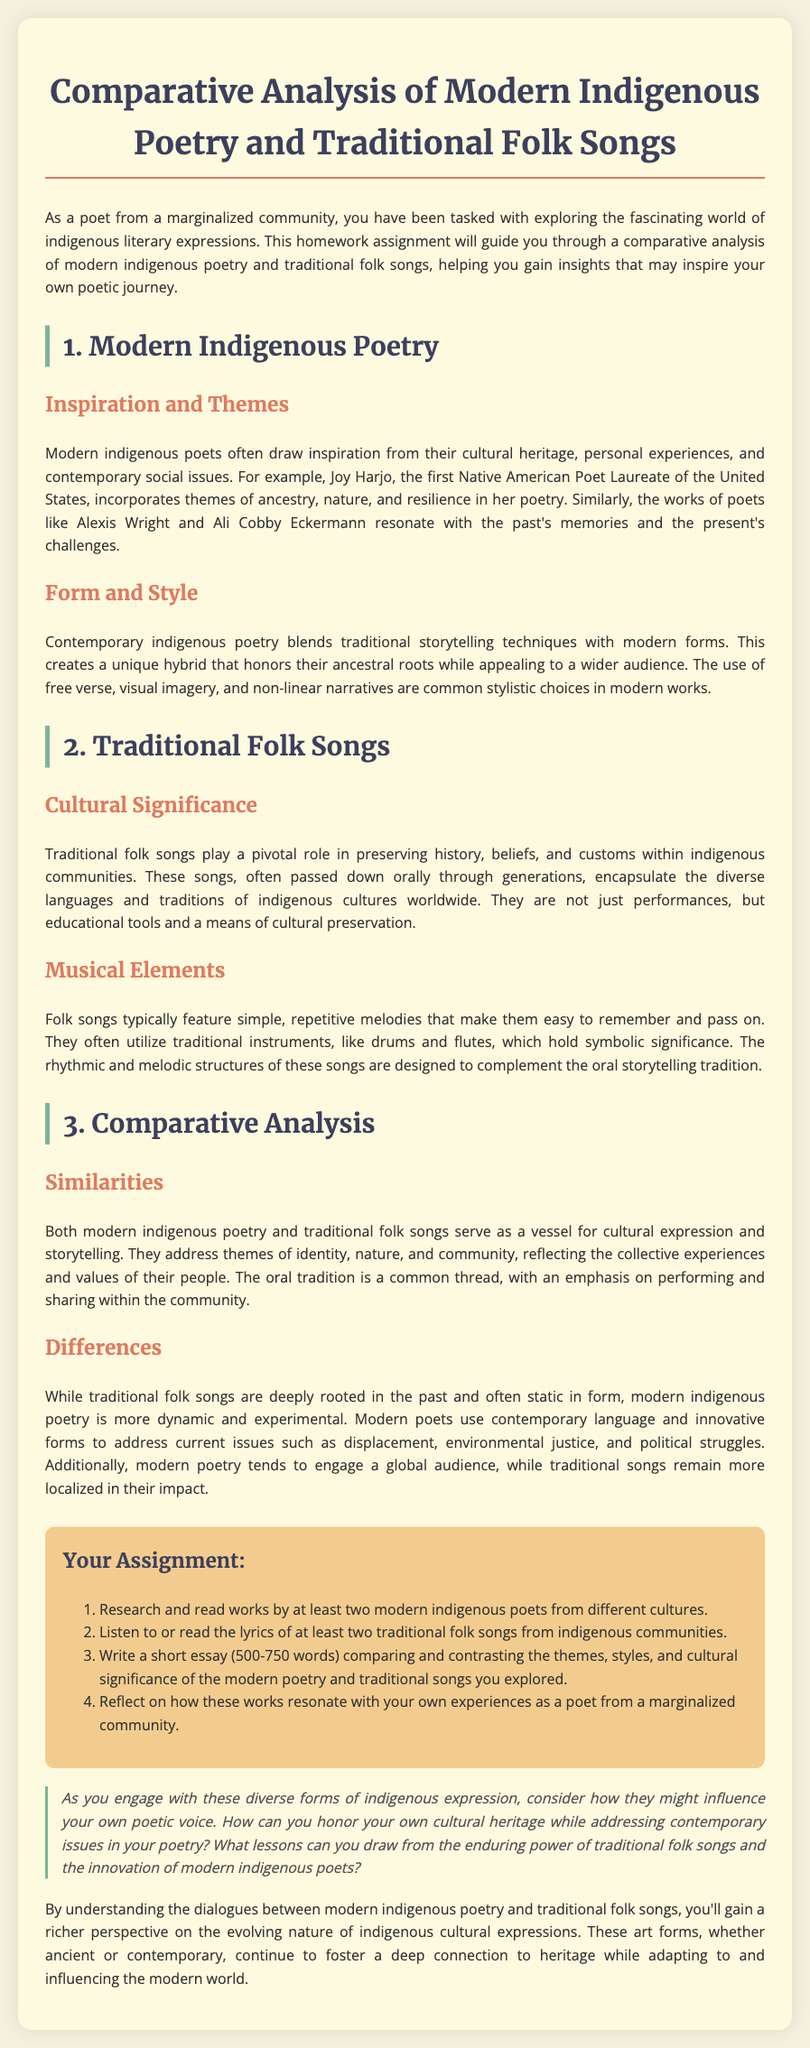what is the title of the homework assignment? The title of the homework assignment is located at the top of the document, which discusses the comparative analysis.
Answer: Comparative Analysis of Modern Indigenous Poetry and Traditional Folk Songs who is the first Native American Poet Laureate of the United States mentioned in the document? The document refers to Joy Harjo as the first Native American Poet Laureate.
Answer: Joy Harjo what do modern indigenous poets often draw inspiration from? The document states that modern indigenous poets draw from their cultural heritage, personal experiences, and contemporary social issues.
Answer: Cultural heritage, personal experiences, and contemporary social issues what is one common stylistic choice in modern indigenous poetry? The document highlights that the use of free verse is a common stylistic choice in contemporary indigenous poetry.
Answer: Free verse what role do traditional folk songs play in indigenous communities? According to the document, traditional folk songs play a pivotal role in preserving history, beliefs, and customs.
Answer: Preserving history, beliefs, and customs how many poets are recommended for research in the assignment? The assignment specifies researching works by at least two modern indigenous poets.
Answer: Two what type of music elements do folk songs typically feature? The document mentions that folk songs typically have simple, repetitive melodies.
Answer: Simple, repetitive melodies what is the word limit for the short essay in the assignment? The assignment outlines a word limit for the comparative essay of between 500 to 750 words.
Answer: 500-750 words what is a common theme in both modern indigenous poetry and traditional folk songs? The document states that themes of identity are shared by both modern poetry and traditional songs.
Answer: Identity 